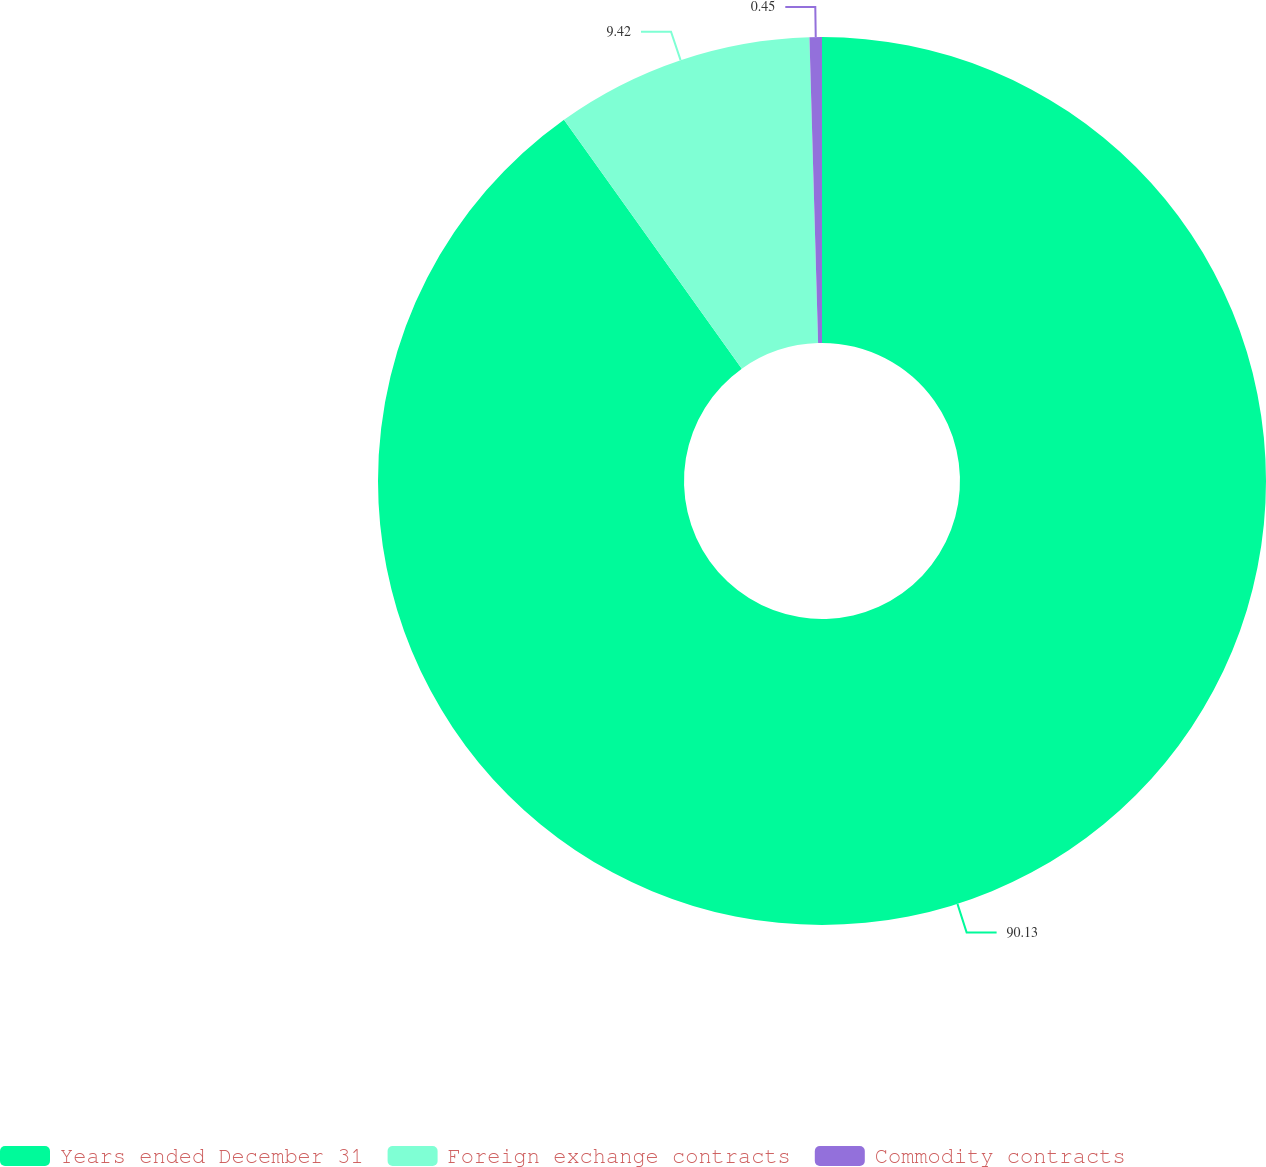<chart> <loc_0><loc_0><loc_500><loc_500><pie_chart><fcel>Years ended December 31<fcel>Foreign exchange contracts<fcel>Commodity contracts<nl><fcel>90.14%<fcel>9.42%<fcel>0.45%<nl></chart> 